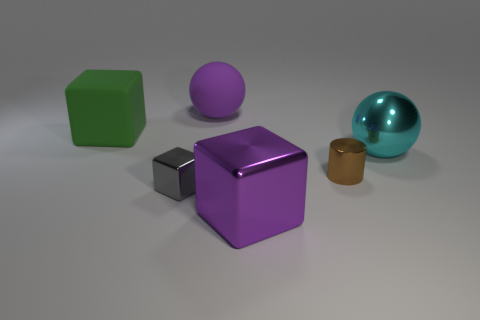How many other objects are there of the same color as the big matte ball?
Your response must be concise. 1. There is a brown object that is the same size as the gray thing; what shape is it?
Give a very brief answer. Cylinder. What number of big things are either yellow matte things or gray objects?
Keep it short and to the point. 0. Are there any small objects that are on the left side of the purple object to the left of the big purple object that is in front of the big cyan metallic object?
Keep it short and to the point. Yes. Is there a shiny object of the same size as the brown metallic cylinder?
Your response must be concise. Yes. There is another ball that is the same size as the purple matte sphere; what is it made of?
Provide a short and direct response. Metal. There is a purple matte thing; does it have the same size as the sphere in front of the green cube?
Your response must be concise. Yes. What number of shiny objects are big green objects or big purple blocks?
Give a very brief answer. 1. How many other big green objects are the same shape as the green object?
Your response must be concise. 0. There is a sphere that is the same color as the big metal cube; what is its material?
Offer a terse response. Rubber. 